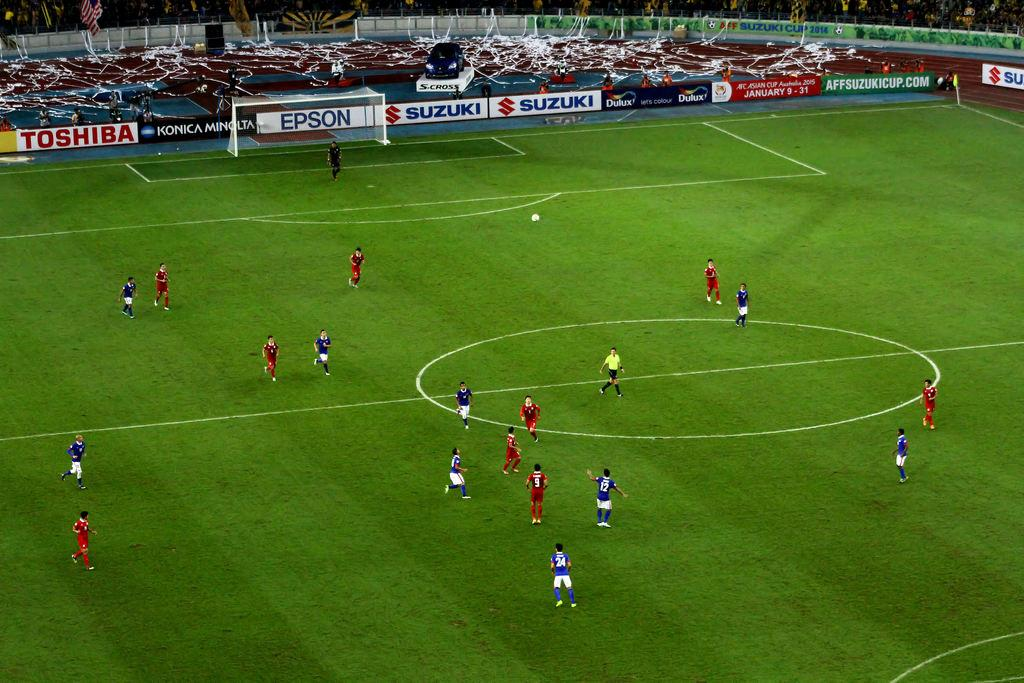<image>
Render a clear and concise summary of the photo. The player in the blue at the very bottom is number 24 